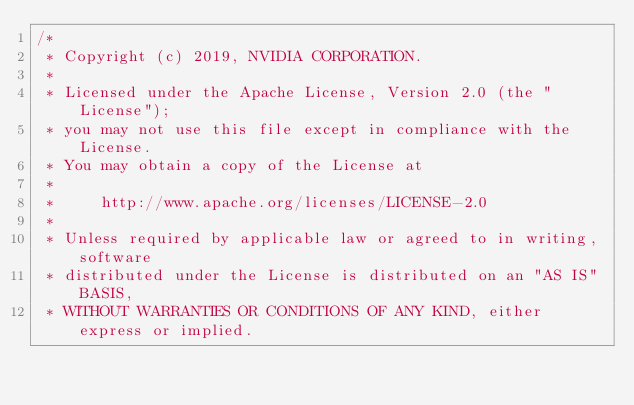Convert code to text. <code><loc_0><loc_0><loc_500><loc_500><_Cuda_>/*
 * Copyright (c) 2019, NVIDIA CORPORATION.
 *
 * Licensed under the Apache License, Version 2.0 (the "License");
 * you may not use this file except in compliance with the License.
 * You may obtain a copy of the License at
 *
 *     http://www.apache.org/licenses/LICENSE-2.0
 *
 * Unless required by applicable law or agreed to in writing, software
 * distributed under the License is distributed on an "AS IS" BASIS,
 * WITHOUT WARRANTIES OR CONDITIONS OF ANY KIND, either express or implied.</code> 